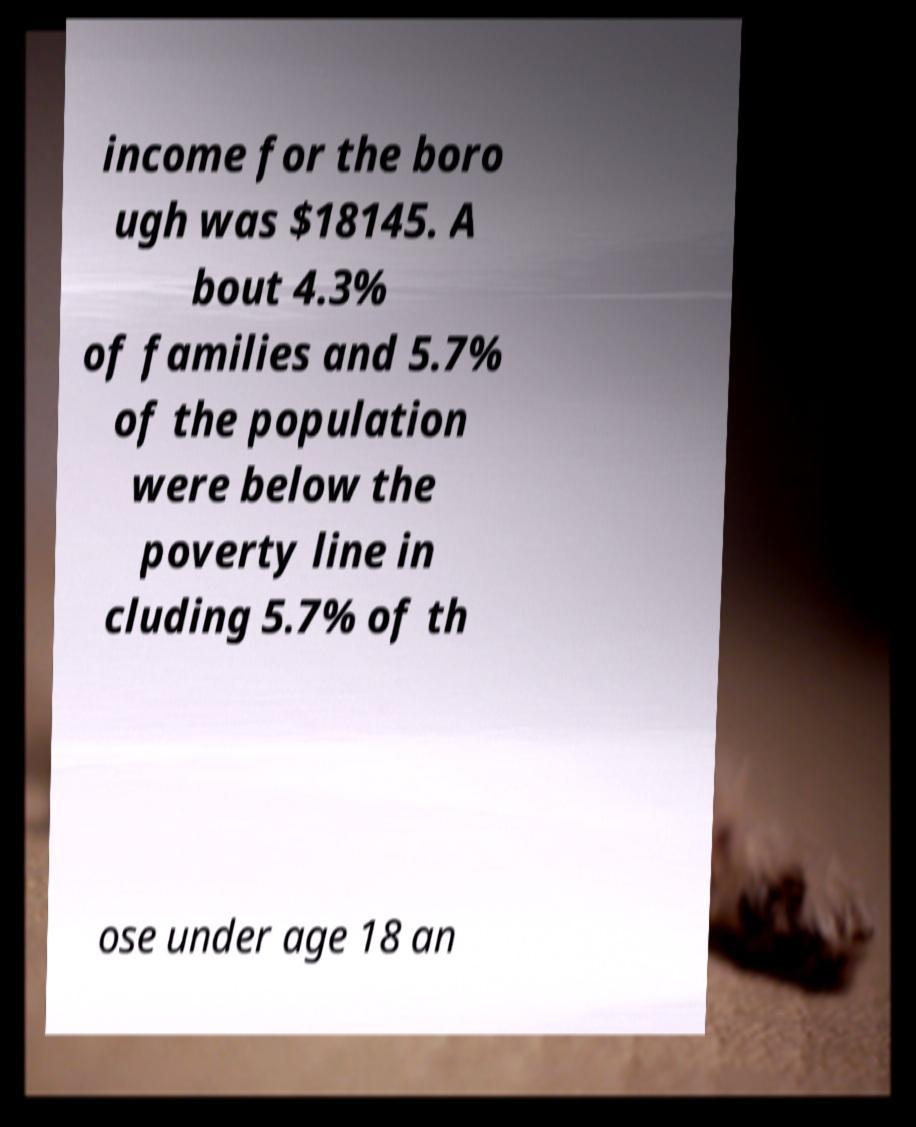Could you extract and type out the text from this image? income for the boro ugh was $18145. A bout 4.3% of families and 5.7% of the population were below the poverty line in cluding 5.7% of th ose under age 18 an 